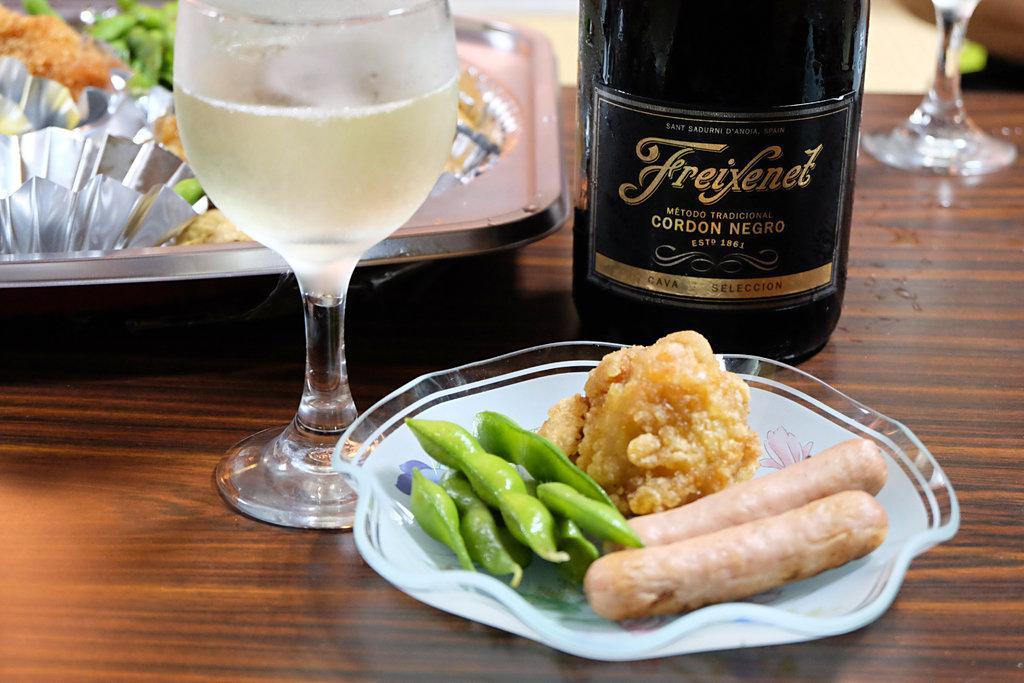In one or two sentences, can you explain what this image depicts? In this image we can see a table. On the table there are a serving plate which has food on it, glass tumbler with beverage in it, beverage bottle and a tray containing food. 